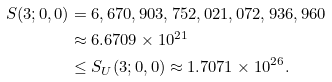<formula> <loc_0><loc_0><loc_500><loc_500>S ( 3 ; 0 , 0 ) & = 6 , 6 7 0 , 9 0 3 , 7 5 2 , 0 2 1 , 0 7 2 , 9 3 6 , 9 6 0 \\ & \approx 6 . 6 7 0 9 \times 1 0 ^ { 2 1 } \\ & \leq S _ { U } ( 3 ; 0 , 0 ) \approx 1 . 7 0 7 1 \times 1 0 ^ { 2 6 } .</formula> 